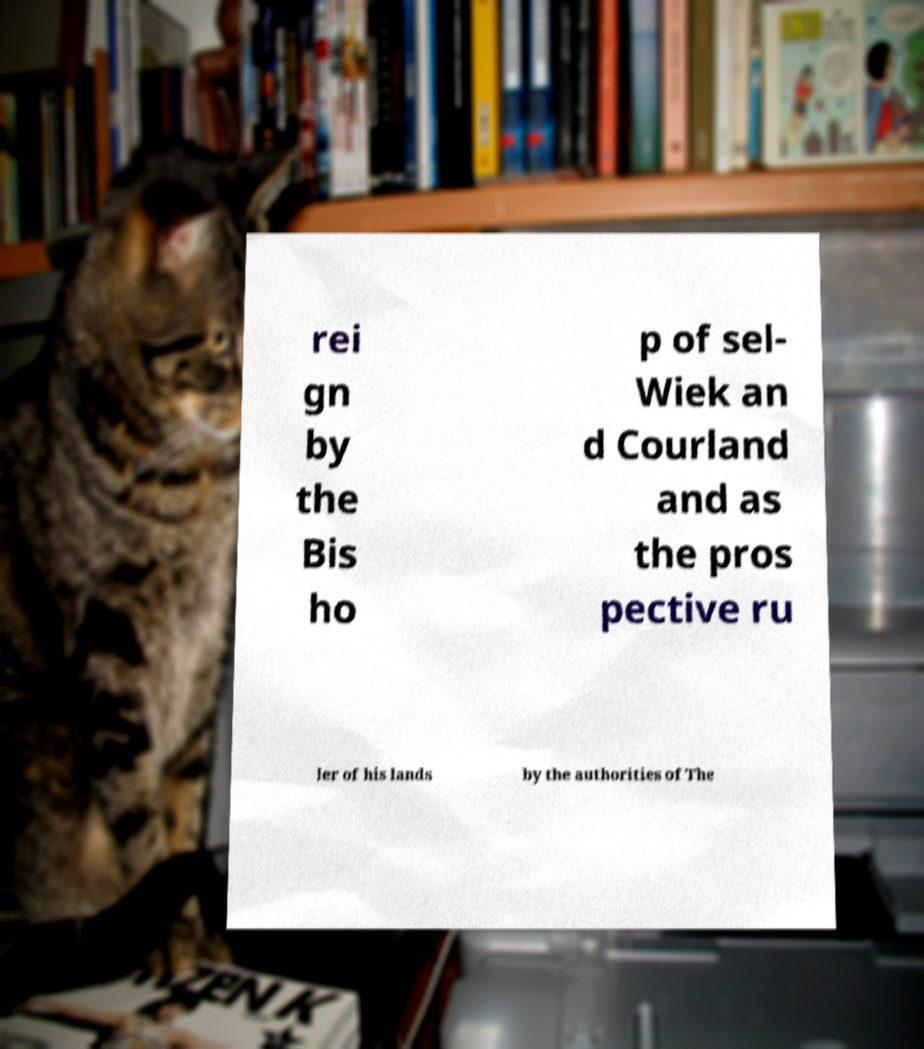Could you assist in decoding the text presented in this image and type it out clearly? rei gn by the Bis ho p of sel- Wiek an d Courland and as the pros pective ru ler of his lands by the authorities of The 